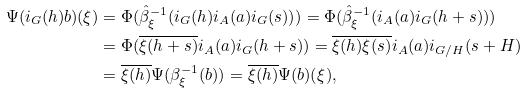<formula> <loc_0><loc_0><loc_500><loc_500>\Psi ( i _ { G } ( h ) b ) ( \xi ) & = \Phi ( \hat { \beta } _ { \xi } ^ { - 1 } ( i _ { G } ( h ) i _ { A } ( a ) i _ { G } ( s ) ) ) = \Phi ( \hat { \beta } _ { \xi } ^ { - 1 } ( i _ { A } ( a ) i _ { G } ( h + s ) ) ) \\ & = \Phi ( \overline { \xi ( h + s ) } i _ { A } ( a ) i _ { G } ( h + s ) ) = \overline { \xi ( h ) \xi ( s ) } i _ { A } ( a ) i _ { G / H } ( s + H ) \\ & = \overline { \xi ( h ) } \Psi ( \beta _ { \xi } ^ { - 1 } ( b ) ) = \overline { \xi ( h ) } \Psi ( b ) ( \xi ) ,</formula> 